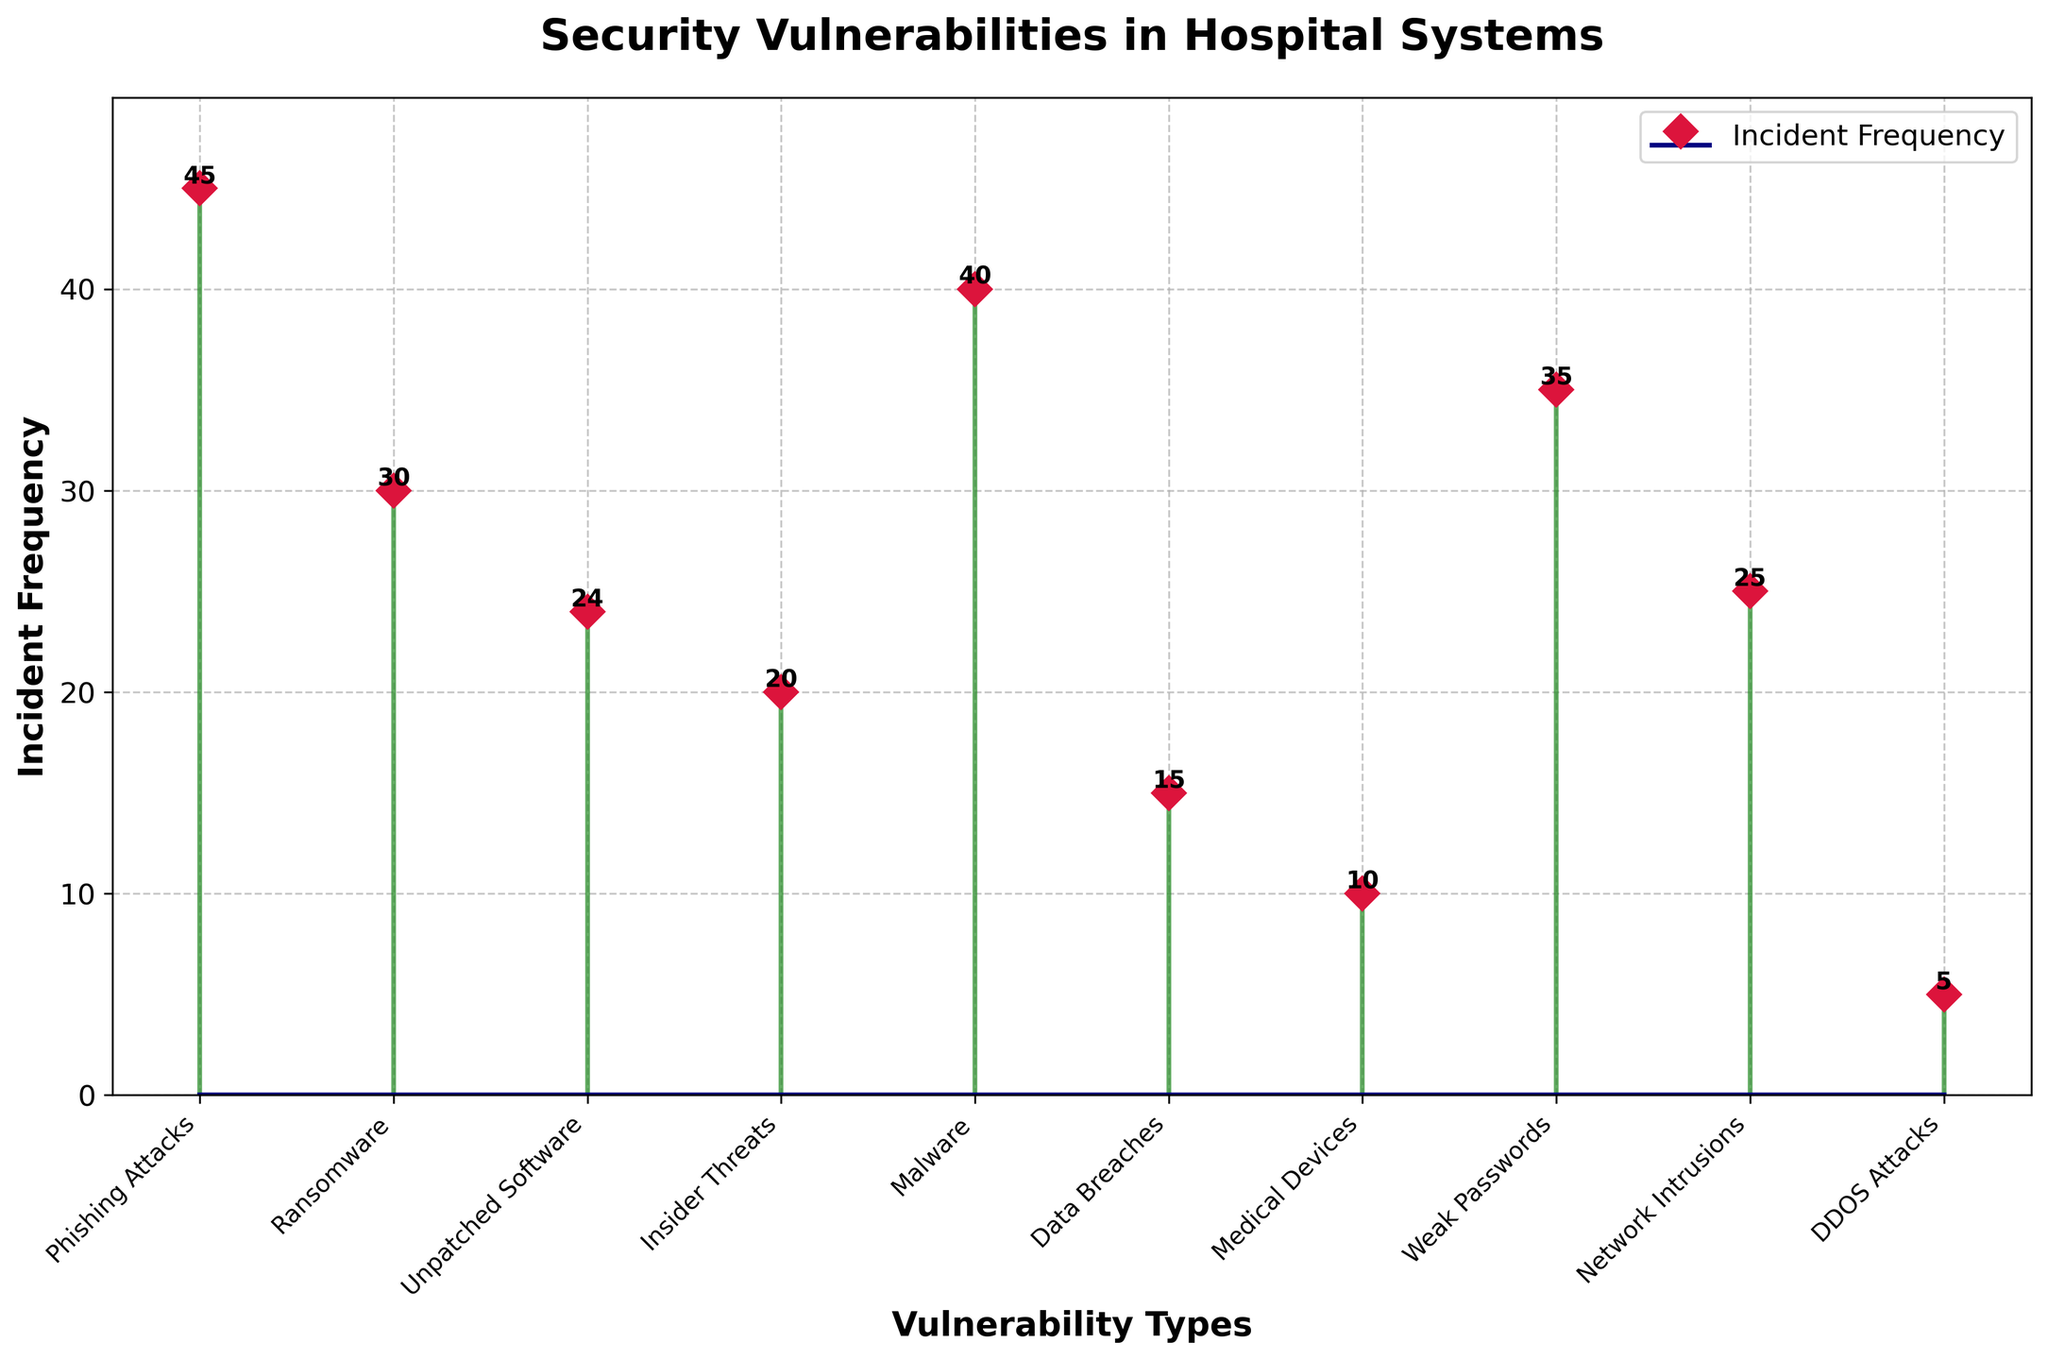What's the title of the figure? The title is located at the top of the figure and reads "Security Vulnerabilities in Hospital Systems".
Answer: Security Vulnerabilities in Hospital Systems How many different types of vulnerabilities are listed in the plot? There are ten different types of vulnerabilities represented as separate data points in the plot.
Answer: Ten What is the frequency of Phishing Attacks incidents? Locate the stem plot point corresponding to "Phishing Attacks" on the x-axis and read the value on the y-axis.
Answer: 45 Which vulnerability type has the lowest incident frequency? Look for the data point with the shortest stem, which represents the minimum frequency. The label near the x-axis will denote the vulnerability type.
Answer: DDOS Attacks What is the difference in incident frequency between Weak Passwords and Insider Threats? Subtract the y-axis value of "Insider Threats" (20) from that of "Weak Passwords" (35) to find the difference. 35 - 20 = 15.
Answer: 15 What is the sum of incident frequencies for Malware and Network Intrusions? Add the y-axis values for "Malware" (40) and "Network Intrusions" (25). 40 + 25 = 65.
Answer: 65 Which three vulnerability types have the highest incident frequencies? Identify the three tallest stems in the plot which correspond to "Phishing Attacks" (45), "Malware" (40), and "Weak Passwords" (35).
Answer: Phishing Attacks, Malware, Weak Passwords Compare the incident frequency of Ransomware to Unpatched Software. Which is higher and by how much? Find the y-axis values for "Ransomware" (30) and "Unpatched Software" (24). Subtract the smaller value from the larger one. 30 - 24 = 6.
Answer: Ransomware is higher by 6 What is the median incident frequency of the vulnerabilities listed? Arrange the ten data points in order: 5, 10, 15, 20, 24, 25, 30, 35, 40, 45. The median is the average of the 5th and 6th values (24 and 25). (24 + 25) / 2 = 24.5.
Answer: 24.5 What color are the stems and markers in the plot? The stems are colored in forest green, and the markers are colored in crimson, as observed visually.
Answer: Stems: forest green, Markers: crimson 